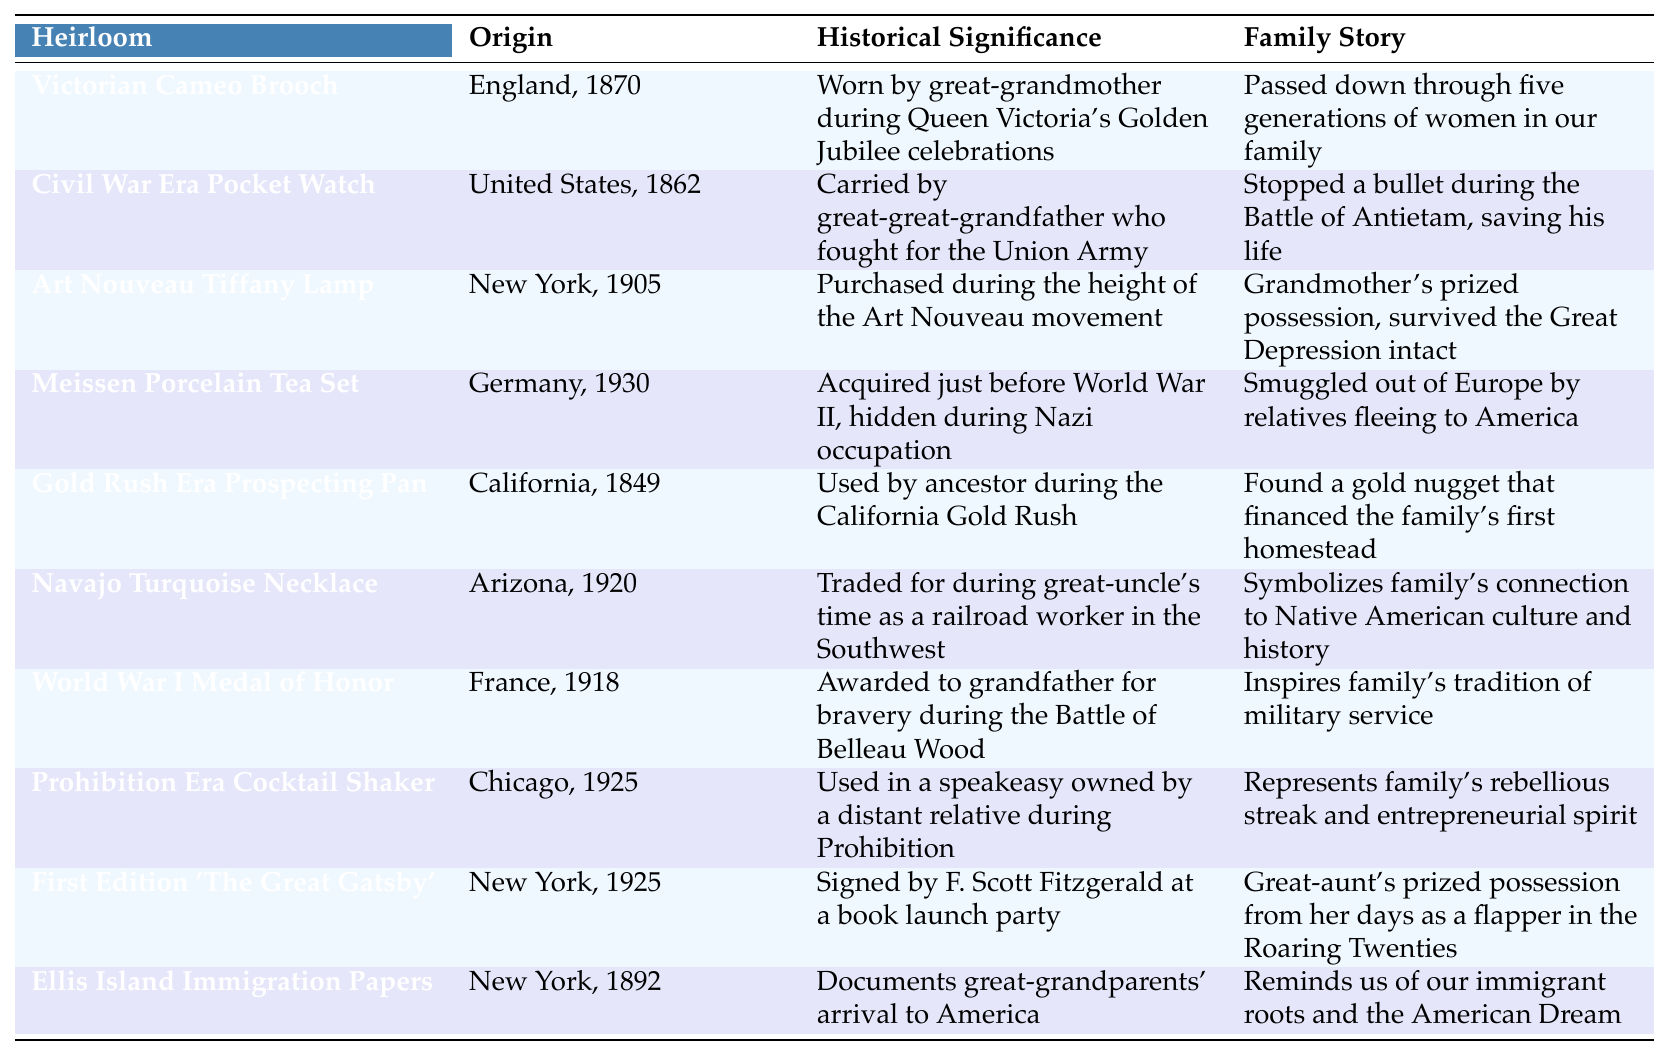What year was the Victorian Cameo Brooch made? The table shows that the Victorian Cameo Brooch's origin is listed as England, 1870. Thus, the year it was made is 1870.
Answer: 1870 Which heirloom has a family story involving surviving the Great Depression? The heirloom that has a family story about surviving the Great Depression is the Art Nouveau Tiffany Lamp, as indicated in the table.
Answer: Art Nouveau Tiffany Lamp What is the historical significance of the Civil War Era Pocket Watch? According to the table, the Civil War Era Pocket Watch's historical significance is that it was carried by a great-great-grandfather who fought for the Union Army.
Answer: Carried by a great-great-grandfather who fought for the Union Army Was the Gold Rush Era Prospecting Pan used before or after 1850? The table states that the Gold Rush Era Prospecting Pan was used in California in 1849, which is before 1850.
Answer: Before 1850 How many heirlooms originated from New York? The table lists three heirlooms originating from New York: the Art Nouveau Tiffany Lamp, the First Edition 'The Great Gatsby', and Ellis Island Immigration Papers. Therefore, there are three items.
Answer: 3 Is the Navajo Turquoise Necklace associated with any specific cultural significance? Yes, the table mentions that the Navajo Turquoise Necklace symbolizes the family's connection to Native American culture and history.
Answer: Yes Which heirloom has a family story related to military service? The heirloom associated with military service is the World War I Medal of Honor, as it inspires the family's tradition of military service.
Answer: World War I Medal of Honor What was the historical significance of the Meissen Porcelain Tea Set during World War II? The historical significance of the Meissen Porcelain Tea Set is that it was acquired just before World War II and hidden during the Nazi occupation, according to the table.
Answer: Hidden during Nazi occupation How many heirlooms were acquired in the 1920s? The table indicates that two heirlooms were acquired in the 1920s: the Navajo Turquoise Necklace in 1920 and the Prohibition Era Cocktail Shaker in 1925. Therefore, there are two items.
Answer: 2 Which heirloom is a reminder of immigrant roots? The Ellis Island Immigration Papers are noted in the table as a reminder of the family's immigrant roots and the American Dream.
Answer: Ellis Island Immigration Papers 